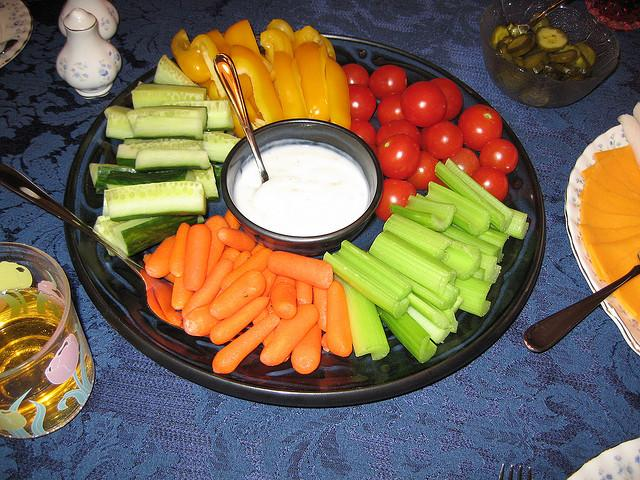What type of utensil is resting in the middle of the bowl in the cup?

Choices:
A) fork
B) knife
C) spoon
D) chopsticks spoon 